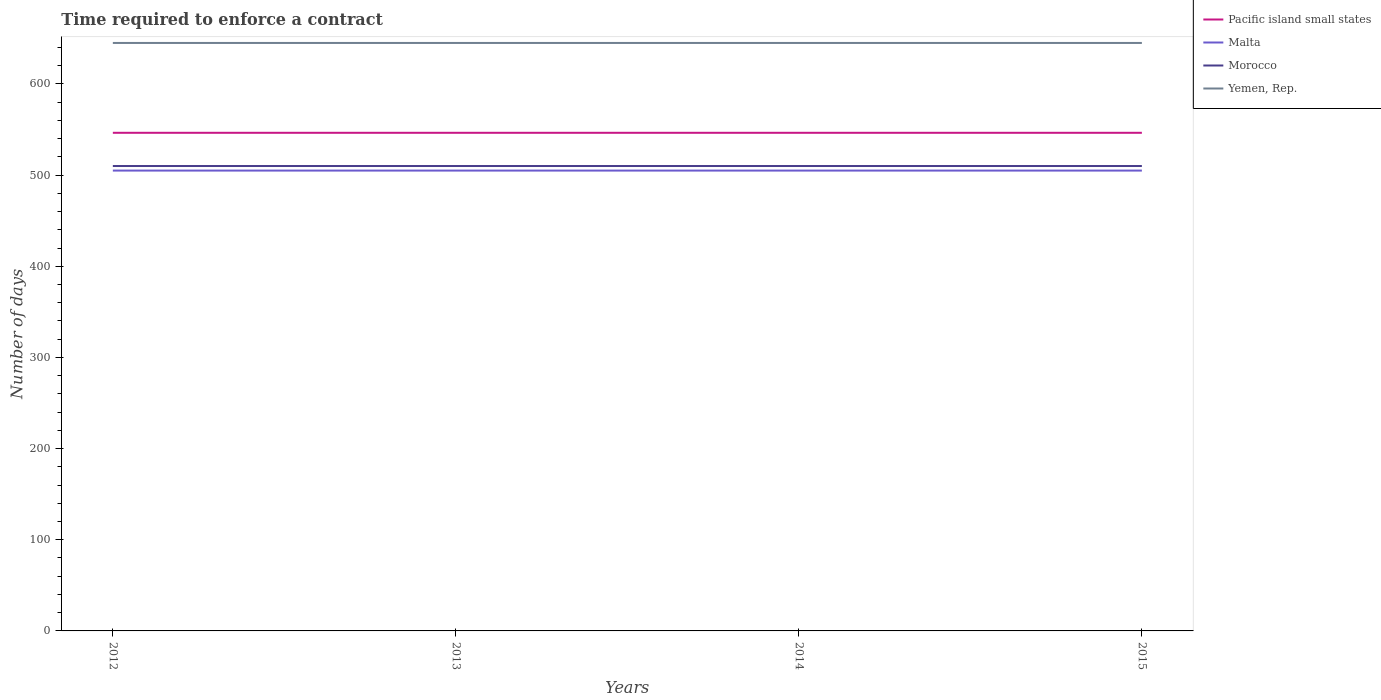Does the line corresponding to Yemen, Rep. intersect with the line corresponding to Pacific island small states?
Your answer should be very brief. No. Is the number of lines equal to the number of legend labels?
Keep it short and to the point. Yes. Across all years, what is the maximum number of days required to enforce a contract in Malta?
Your answer should be very brief. 505. In which year was the number of days required to enforce a contract in Morocco maximum?
Provide a succinct answer. 2012. What is the difference between the highest and the second highest number of days required to enforce a contract in Yemen, Rep.?
Offer a terse response. 0. Is the number of days required to enforce a contract in Morocco strictly greater than the number of days required to enforce a contract in Pacific island small states over the years?
Give a very brief answer. Yes. How many lines are there?
Your answer should be compact. 4. Are the values on the major ticks of Y-axis written in scientific E-notation?
Make the answer very short. No. Does the graph contain any zero values?
Your answer should be compact. No. Does the graph contain grids?
Your answer should be compact. No. How many legend labels are there?
Keep it short and to the point. 4. What is the title of the graph?
Provide a succinct answer. Time required to enforce a contract. What is the label or title of the X-axis?
Offer a very short reply. Years. What is the label or title of the Y-axis?
Give a very brief answer. Number of days. What is the Number of days in Pacific island small states in 2012?
Provide a short and direct response. 546.44. What is the Number of days in Malta in 2012?
Ensure brevity in your answer.  505. What is the Number of days in Morocco in 2012?
Keep it short and to the point. 510. What is the Number of days of Yemen, Rep. in 2012?
Give a very brief answer. 645. What is the Number of days in Pacific island small states in 2013?
Give a very brief answer. 546.44. What is the Number of days of Malta in 2013?
Your answer should be compact. 505. What is the Number of days in Morocco in 2013?
Offer a very short reply. 510. What is the Number of days of Yemen, Rep. in 2013?
Offer a terse response. 645. What is the Number of days of Pacific island small states in 2014?
Ensure brevity in your answer.  546.44. What is the Number of days in Malta in 2014?
Your response must be concise. 505. What is the Number of days of Morocco in 2014?
Make the answer very short. 510. What is the Number of days in Yemen, Rep. in 2014?
Offer a terse response. 645. What is the Number of days of Pacific island small states in 2015?
Make the answer very short. 546.44. What is the Number of days in Malta in 2015?
Offer a very short reply. 505. What is the Number of days of Morocco in 2015?
Provide a short and direct response. 510. What is the Number of days of Yemen, Rep. in 2015?
Keep it short and to the point. 645. Across all years, what is the maximum Number of days of Pacific island small states?
Provide a succinct answer. 546.44. Across all years, what is the maximum Number of days in Malta?
Offer a very short reply. 505. Across all years, what is the maximum Number of days of Morocco?
Give a very brief answer. 510. Across all years, what is the maximum Number of days in Yemen, Rep.?
Your response must be concise. 645. Across all years, what is the minimum Number of days in Pacific island small states?
Ensure brevity in your answer.  546.44. Across all years, what is the minimum Number of days of Malta?
Your answer should be very brief. 505. Across all years, what is the minimum Number of days of Morocco?
Your answer should be compact. 510. Across all years, what is the minimum Number of days in Yemen, Rep.?
Keep it short and to the point. 645. What is the total Number of days of Pacific island small states in the graph?
Ensure brevity in your answer.  2185.78. What is the total Number of days in Malta in the graph?
Give a very brief answer. 2020. What is the total Number of days in Morocco in the graph?
Make the answer very short. 2040. What is the total Number of days in Yemen, Rep. in the graph?
Offer a terse response. 2580. What is the difference between the Number of days of Yemen, Rep. in 2012 and that in 2013?
Offer a terse response. 0. What is the difference between the Number of days in Malta in 2012 and that in 2014?
Provide a succinct answer. 0. What is the difference between the Number of days in Morocco in 2012 and that in 2014?
Give a very brief answer. 0. What is the difference between the Number of days in Malta in 2012 and that in 2015?
Give a very brief answer. 0. What is the difference between the Number of days in Yemen, Rep. in 2012 and that in 2015?
Make the answer very short. 0. What is the difference between the Number of days of Pacific island small states in 2013 and that in 2014?
Your response must be concise. 0. What is the difference between the Number of days of Morocco in 2013 and that in 2014?
Your response must be concise. 0. What is the difference between the Number of days in Malta in 2013 and that in 2015?
Keep it short and to the point. 0. What is the difference between the Number of days of Morocco in 2013 and that in 2015?
Offer a terse response. 0. What is the difference between the Number of days of Yemen, Rep. in 2013 and that in 2015?
Keep it short and to the point. 0. What is the difference between the Number of days of Malta in 2014 and that in 2015?
Your answer should be very brief. 0. What is the difference between the Number of days in Morocco in 2014 and that in 2015?
Offer a very short reply. 0. What is the difference between the Number of days of Pacific island small states in 2012 and the Number of days of Malta in 2013?
Provide a short and direct response. 41.44. What is the difference between the Number of days of Pacific island small states in 2012 and the Number of days of Morocco in 2013?
Offer a terse response. 36.44. What is the difference between the Number of days of Pacific island small states in 2012 and the Number of days of Yemen, Rep. in 2013?
Provide a succinct answer. -98.56. What is the difference between the Number of days of Malta in 2012 and the Number of days of Yemen, Rep. in 2013?
Offer a very short reply. -140. What is the difference between the Number of days in Morocco in 2012 and the Number of days in Yemen, Rep. in 2013?
Offer a very short reply. -135. What is the difference between the Number of days in Pacific island small states in 2012 and the Number of days in Malta in 2014?
Make the answer very short. 41.44. What is the difference between the Number of days of Pacific island small states in 2012 and the Number of days of Morocco in 2014?
Offer a very short reply. 36.44. What is the difference between the Number of days in Pacific island small states in 2012 and the Number of days in Yemen, Rep. in 2014?
Offer a very short reply. -98.56. What is the difference between the Number of days in Malta in 2012 and the Number of days in Morocco in 2014?
Give a very brief answer. -5. What is the difference between the Number of days of Malta in 2012 and the Number of days of Yemen, Rep. in 2014?
Offer a very short reply. -140. What is the difference between the Number of days in Morocco in 2012 and the Number of days in Yemen, Rep. in 2014?
Ensure brevity in your answer.  -135. What is the difference between the Number of days of Pacific island small states in 2012 and the Number of days of Malta in 2015?
Keep it short and to the point. 41.44. What is the difference between the Number of days in Pacific island small states in 2012 and the Number of days in Morocco in 2015?
Offer a terse response. 36.44. What is the difference between the Number of days in Pacific island small states in 2012 and the Number of days in Yemen, Rep. in 2015?
Your response must be concise. -98.56. What is the difference between the Number of days of Malta in 2012 and the Number of days of Yemen, Rep. in 2015?
Make the answer very short. -140. What is the difference between the Number of days in Morocco in 2012 and the Number of days in Yemen, Rep. in 2015?
Your response must be concise. -135. What is the difference between the Number of days in Pacific island small states in 2013 and the Number of days in Malta in 2014?
Offer a very short reply. 41.44. What is the difference between the Number of days in Pacific island small states in 2013 and the Number of days in Morocco in 2014?
Offer a very short reply. 36.44. What is the difference between the Number of days of Pacific island small states in 2013 and the Number of days of Yemen, Rep. in 2014?
Your answer should be very brief. -98.56. What is the difference between the Number of days in Malta in 2013 and the Number of days in Yemen, Rep. in 2014?
Offer a very short reply. -140. What is the difference between the Number of days of Morocco in 2013 and the Number of days of Yemen, Rep. in 2014?
Offer a terse response. -135. What is the difference between the Number of days in Pacific island small states in 2013 and the Number of days in Malta in 2015?
Your answer should be compact. 41.44. What is the difference between the Number of days of Pacific island small states in 2013 and the Number of days of Morocco in 2015?
Give a very brief answer. 36.44. What is the difference between the Number of days of Pacific island small states in 2013 and the Number of days of Yemen, Rep. in 2015?
Your answer should be very brief. -98.56. What is the difference between the Number of days in Malta in 2013 and the Number of days in Morocco in 2015?
Offer a terse response. -5. What is the difference between the Number of days of Malta in 2013 and the Number of days of Yemen, Rep. in 2015?
Provide a short and direct response. -140. What is the difference between the Number of days of Morocco in 2013 and the Number of days of Yemen, Rep. in 2015?
Give a very brief answer. -135. What is the difference between the Number of days of Pacific island small states in 2014 and the Number of days of Malta in 2015?
Your answer should be compact. 41.44. What is the difference between the Number of days in Pacific island small states in 2014 and the Number of days in Morocco in 2015?
Your answer should be very brief. 36.44. What is the difference between the Number of days of Pacific island small states in 2014 and the Number of days of Yemen, Rep. in 2015?
Ensure brevity in your answer.  -98.56. What is the difference between the Number of days of Malta in 2014 and the Number of days of Yemen, Rep. in 2015?
Provide a short and direct response. -140. What is the difference between the Number of days of Morocco in 2014 and the Number of days of Yemen, Rep. in 2015?
Your response must be concise. -135. What is the average Number of days of Pacific island small states per year?
Ensure brevity in your answer.  546.44. What is the average Number of days in Malta per year?
Your answer should be very brief. 505. What is the average Number of days of Morocco per year?
Your answer should be compact. 510. What is the average Number of days in Yemen, Rep. per year?
Provide a succinct answer. 645. In the year 2012, what is the difference between the Number of days of Pacific island small states and Number of days of Malta?
Your answer should be very brief. 41.44. In the year 2012, what is the difference between the Number of days in Pacific island small states and Number of days in Morocco?
Provide a short and direct response. 36.44. In the year 2012, what is the difference between the Number of days of Pacific island small states and Number of days of Yemen, Rep.?
Offer a terse response. -98.56. In the year 2012, what is the difference between the Number of days of Malta and Number of days of Yemen, Rep.?
Your answer should be very brief. -140. In the year 2012, what is the difference between the Number of days in Morocco and Number of days in Yemen, Rep.?
Give a very brief answer. -135. In the year 2013, what is the difference between the Number of days in Pacific island small states and Number of days in Malta?
Make the answer very short. 41.44. In the year 2013, what is the difference between the Number of days in Pacific island small states and Number of days in Morocco?
Provide a short and direct response. 36.44. In the year 2013, what is the difference between the Number of days in Pacific island small states and Number of days in Yemen, Rep.?
Your answer should be very brief. -98.56. In the year 2013, what is the difference between the Number of days in Malta and Number of days in Yemen, Rep.?
Provide a succinct answer. -140. In the year 2013, what is the difference between the Number of days in Morocco and Number of days in Yemen, Rep.?
Provide a succinct answer. -135. In the year 2014, what is the difference between the Number of days of Pacific island small states and Number of days of Malta?
Provide a short and direct response. 41.44. In the year 2014, what is the difference between the Number of days in Pacific island small states and Number of days in Morocco?
Offer a terse response. 36.44. In the year 2014, what is the difference between the Number of days in Pacific island small states and Number of days in Yemen, Rep.?
Provide a short and direct response. -98.56. In the year 2014, what is the difference between the Number of days in Malta and Number of days in Yemen, Rep.?
Offer a terse response. -140. In the year 2014, what is the difference between the Number of days in Morocco and Number of days in Yemen, Rep.?
Keep it short and to the point. -135. In the year 2015, what is the difference between the Number of days of Pacific island small states and Number of days of Malta?
Your answer should be very brief. 41.44. In the year 2015, what is the difference between the Number of days in Pacific island small states and Number of days in Morocco?
Provide a short and direct response. 36.44. In the year 2015, what is the difference between the Number of days in Pacific island small states and Number of days in Yemen, Rep.?
Your answer should be very brief. -98.56. In the year 2015, what is the difference between the Number of days of Malta and Number of days of Morocco?
Make the answer very short. -5. In the year 2015, what is the difference between the Number of days of Malta and Number of days of Yemen, Rep.?
Ensure brevity in your answer.  -140. In the year 2015, what is the difference between the Number of days in Morocco and Number of days in Yemen, Rep.?
Your answer should be very brief. -135. What is the ratio of the Number of days in Morocco in 2012 to that in 2013?
Ensure brevity in your answer.  1. What is the ratio of the Number of days in Yemen, Rep. in 2012 to that in 2013?
Offer a very short reply. 1. What is the ratio of the Number of days in Malta in 2012 to that in 2014?
Offer a very short reply. 1. What is the ratio of the Number of days in Morocco in 2012 to that in 2014?
Provide a short and direct response. 1. What is the ratio of the Number of days of Pacific island small states in 2012 to that in 2015?
Give a very brief answer. 1. What is the ratio of the Number of days of Yemen, Rep. in 2013 to that in 2014?
Provide a succinct answer. 1. What is the ratio of the Number of days in Pacific island small states in 2013 to that in 2015?
Give a very brief answer. 1. What is the ratio of the Number of days in Yemen, Rep. in 2013 to that in 2015?
Provide a short and direct response. 1. What is the difference between the highest and the second highest Number of days in Pacific island small states?
Your answer should be very brief. 0. What is the difference between the highest and the second highest Number of days in Malta?
Your response must be concise. 0. What is the difference between the highest and the second highest Number of days in Morocco?
Offer a very short reply. 0. What is the difference between the highest and the lowest Number of days of Pacific island small states?
Offer a very short reply. 0. 